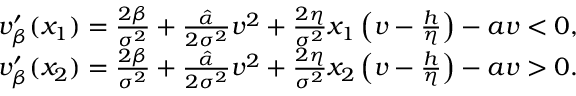<formula> <loc_0><loc_0><loc_500><loc_500>\begin{array} { r } { v _ { \beta } ^ { \prime } ( x _ { 1 } ) = \frac { 2 \beta } { \sigma ^ { 2 } } + \frac { \hat { \alpha } } { 2 \sigma ^ { 2 } } v ^ { 2 } + \frac { 2 \eta } { \sigma ^ { 2 } } x _ { 1 } \left ( v - \frac { h } { \eta } \right ) - a v < 0 , } \\ { v _ { \beta } ^ { \prime } ( x _ { 2 } ) = \frac { 2 \beta } { \sigma ^ { 2 } } + \frac { \hat { \alpha } } { 2 \sigma ^ { 2 } } v ^ { 2 } + \frac { 2 \eta } { \sigma ^ { 2 } } x _ { 2 } \left ( v - \frac { h } { \eta } \right ) - a v > 0 . } \end{array}</formula> 